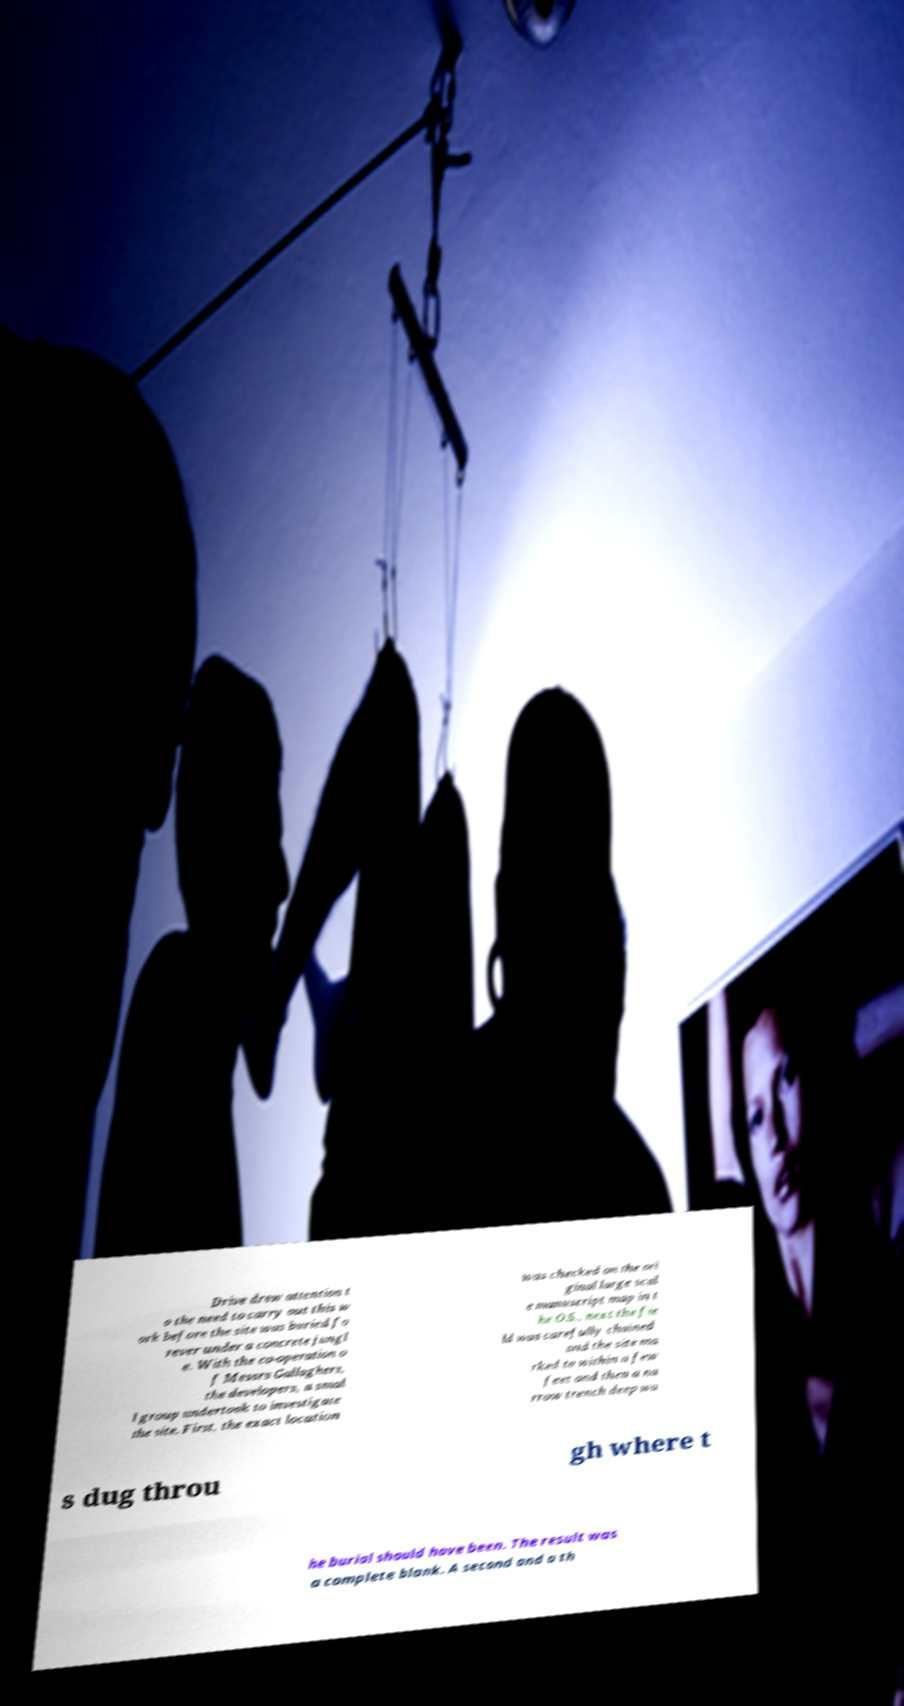For documentation purposes, I need the text within this image transcribed. Could you provide that? Drive drew attention t o the need to carry out this w ork before the site was buried fo rever under a concrete jungl e. With the co-operation o f Messrs Gallaghers, the developers, a smal l group undertook to investigate the site. First, the exact location was checked on the ori ginal large scal e manuscript map in t he O.S., next the fie ld was carefully chained and the site ma rked to within a few feet and then a na rrow trench deep wa s dug throu gh where t he burial should have been. The result was a complete blank. A second and a th 